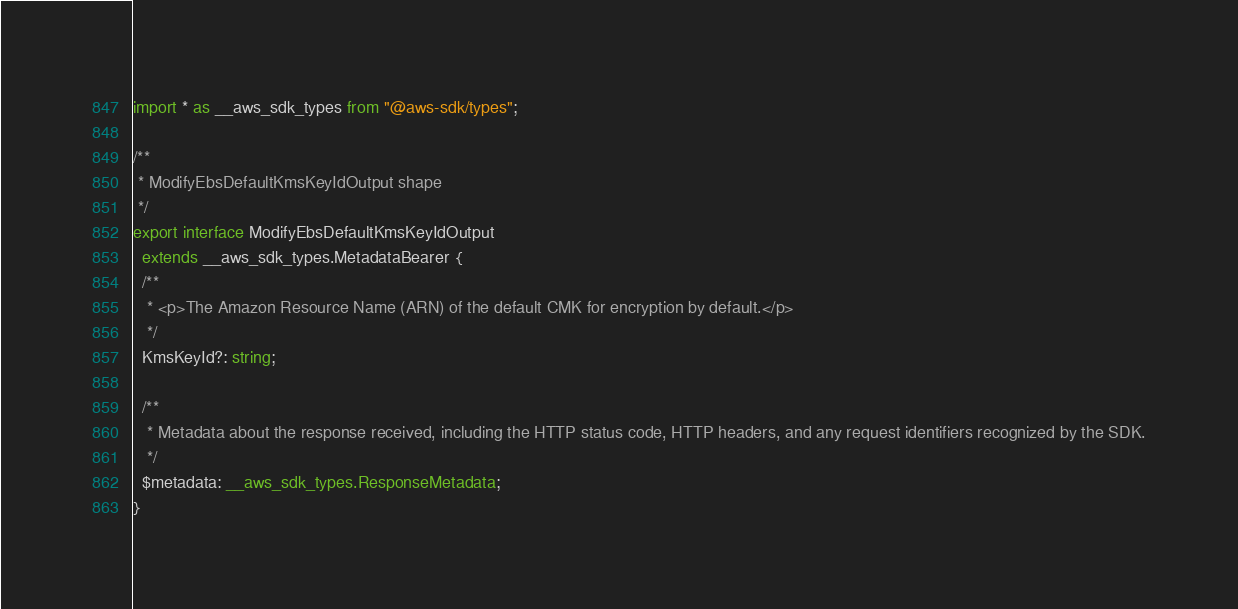Convert code to text. <code><loc_0><loc_0><loc_500><loc_500><_TypeScript_>import * as __aws_sdk_types from "@aws-sdk/types";

/**
 * ModifyEbsDefaultKmsKeyIdOutput shape
 */
export interface ModifyEbsDefaultKmsKeyIdOutput
  extends __aws_sdk_types.MetadataBearer {
  /**
   * <p>The Amazon Resource Name (ARN) of the default CMK for encryption by default.</p>
   */
  KmsKeyId?: string;

  /**
   * Metadata about the response received, including the HTTP status code, HTTP headers, and any request identifiers recognized by the SDK.
   */
  $metadata: __aws_sdk_types.ResponseMetadata;
}
</code> 